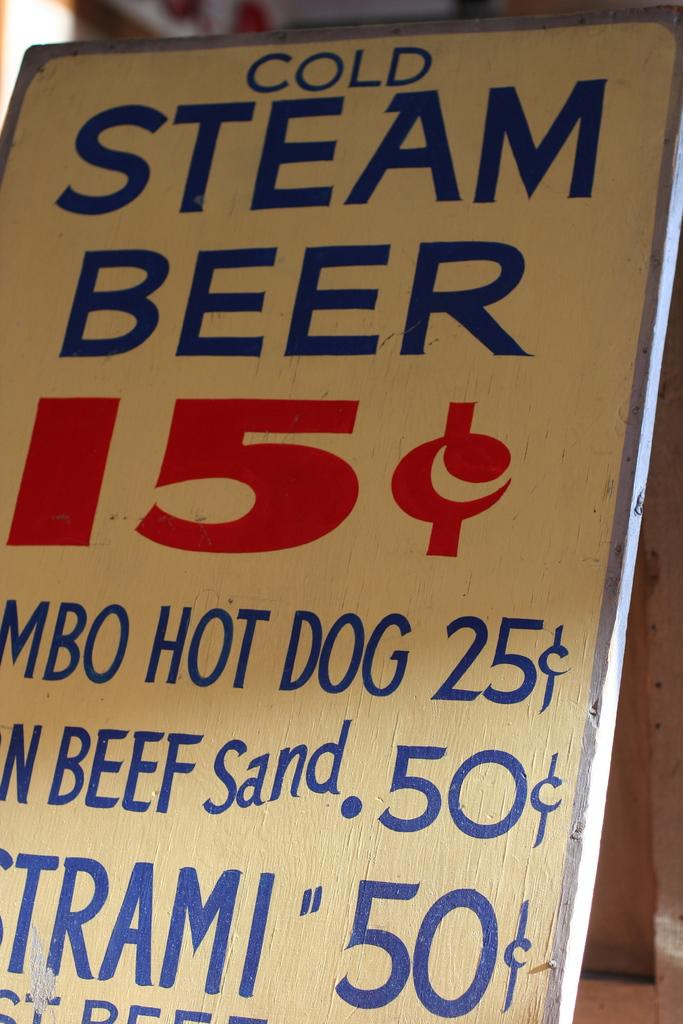<image>
Offer a succinct explanation of the picture presented. An advertisement showing cold steam beer for fifteen cents. 